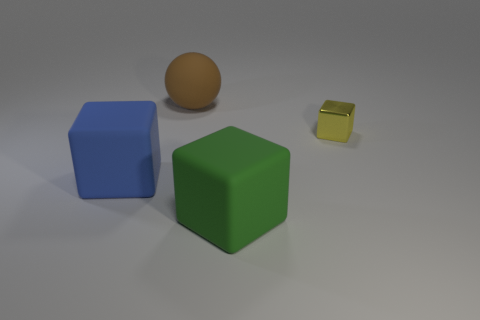What is the shape of the blue thing that is the same material as the big brown thing?
Offer a very short reply. Cube. What number of metallic objects are either big blue things or small gray cylinders?
Your answer should be very brief. 0. What number of green matte things are in front of the big matte block on the left side of the big brown rubber sphere?
Your response must be concise. 1. How many large green blocks are made of the same material as the blue object?
Offer a very short reply. 1. What number of large things are yellow blocks or blue metallic things?
Offer a terse response. 0. What shape is the large rubber object that is both in front of the yellow thing and on the left side of the green cube?
Offer a terse response. Cube. Do the blue thing and the large green thing have the same material?
Offer a terse response. Yes. The other matte cube that is the same size as the green cube is what color?
Ensure brevity in your answer.  Blue. What is the color of the thing that is both behind the large blue matte object and on the left side of the yellow block?
Keep it short and to the point. Brown. How big is the rubber block behind the large rubber block that is on the right side of the big block that is on the left side of the green matte cube?
Offer a very short reply. Large. 